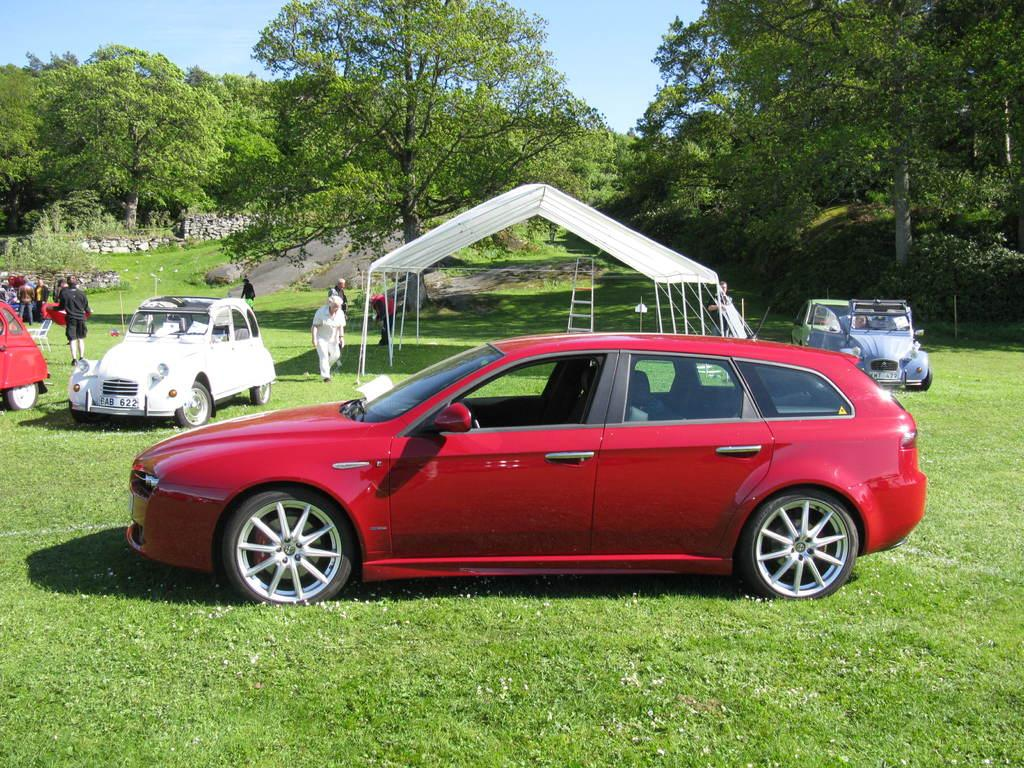What type of vehicles can be seen in the image? There are cars in the image. Can you describe the people in the image? There are people in the image. What is the color of the grass in the image? The grass in the image is green. What can be seen in the background of the image? There are trees, plants, and stones in the background of the image. What color is the sky in the image? The sky is blue in the image. Can you tell me how many yaks are grazing on the grass in the image? There are no yaks present in the image; it features cars, people, and green grass. What type of pencil is being used by the person in the image? There is no pencil visible in the image; it features cars, people, and green grass. 